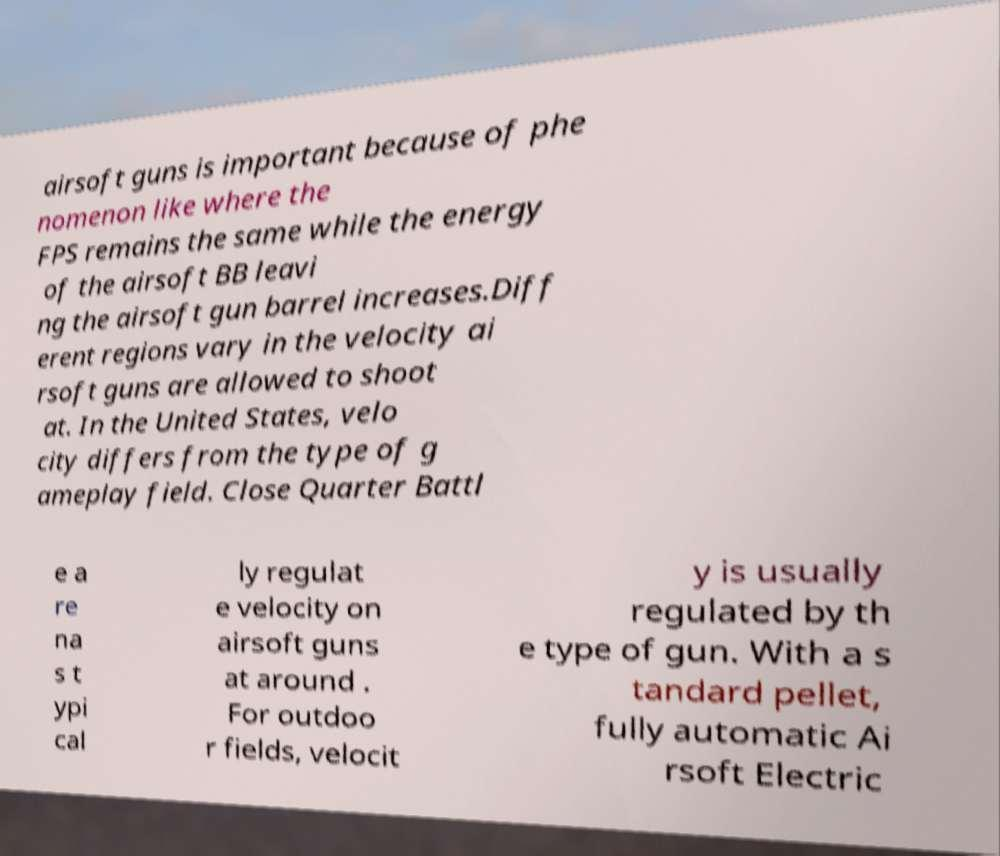Please read and relay the text visible in this image. What does it say? airsoft guns is important because of phe nomenon like where the FPS remains the same while the energy of the airsoft BB leavi ng the airsoft gun barrel increases.Diff erent regions vary in the velocity ai rsoft guns are allowed to shoot at. In the United States, velo city differs from the type of g ameplay field. Close Quarter Battl e a re na s t ypi cal ly regulat e velocity on airsoft guns at around . For outdoo r fields, velocit y is usually regulated by th e type of gun. With a s tandard pellet, fully automatic Ai rsoft Electric 